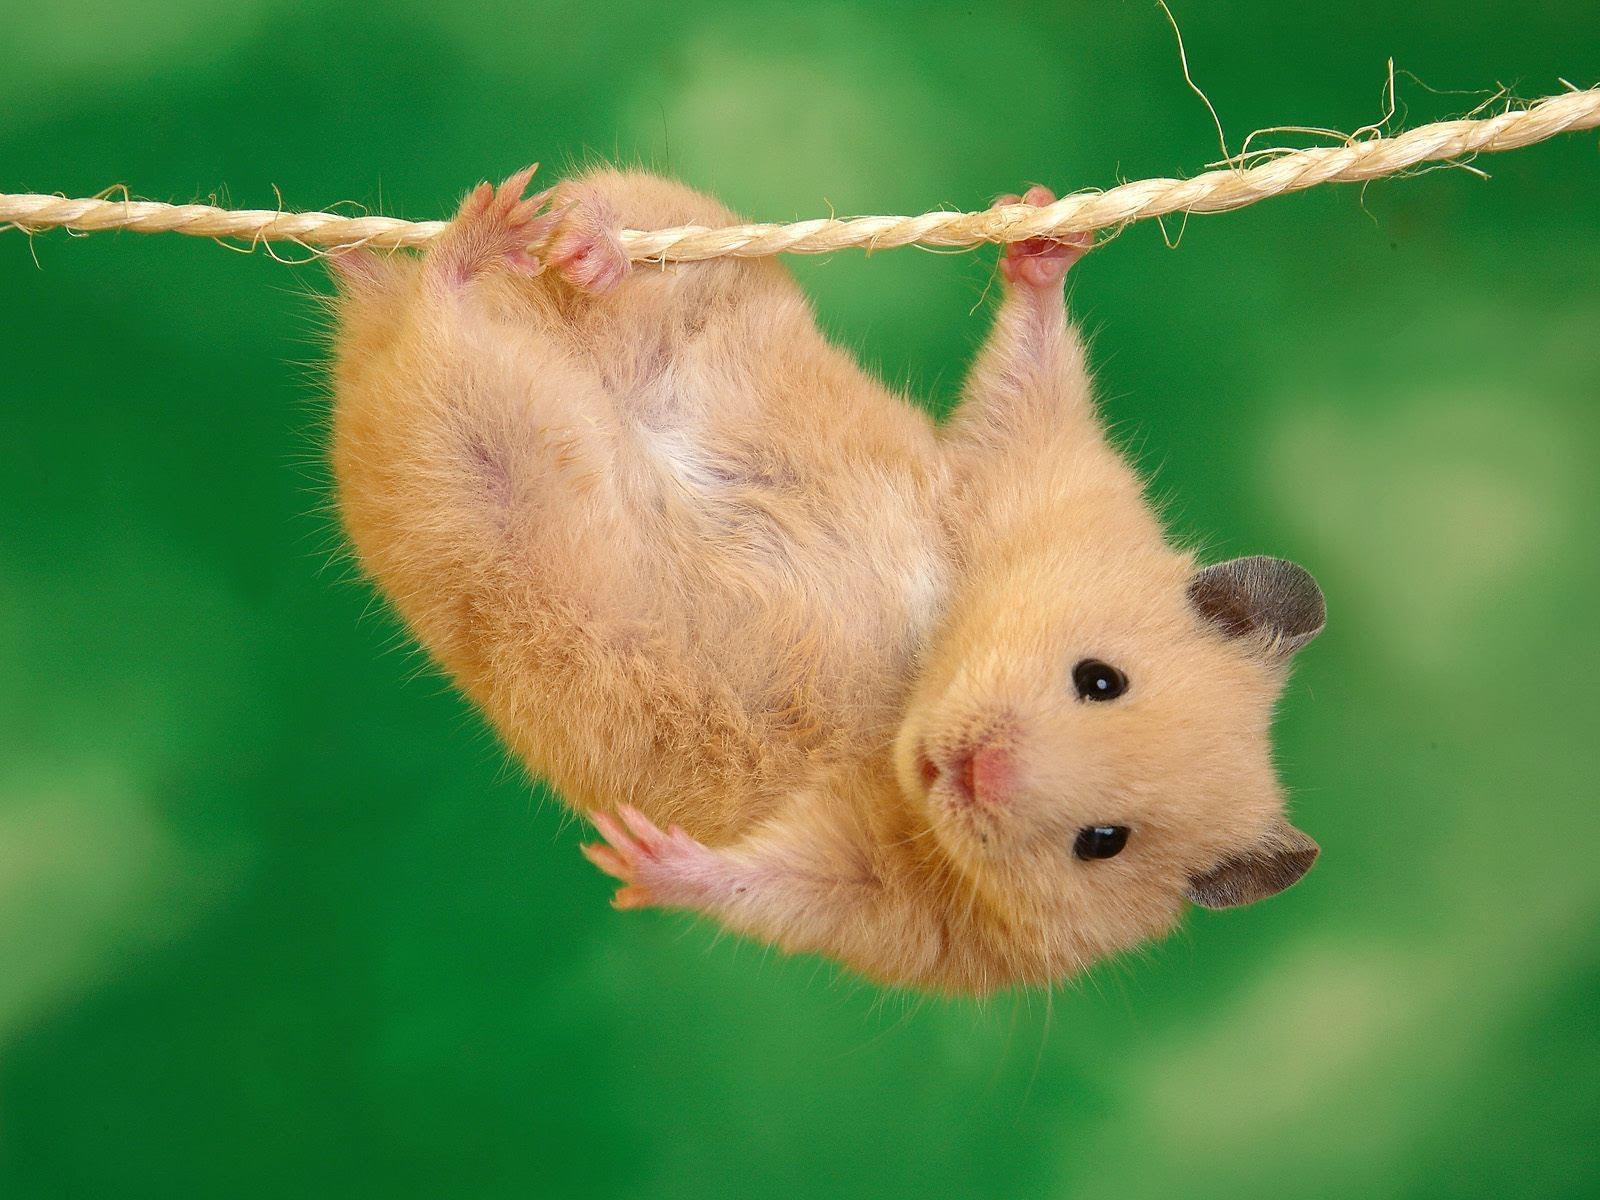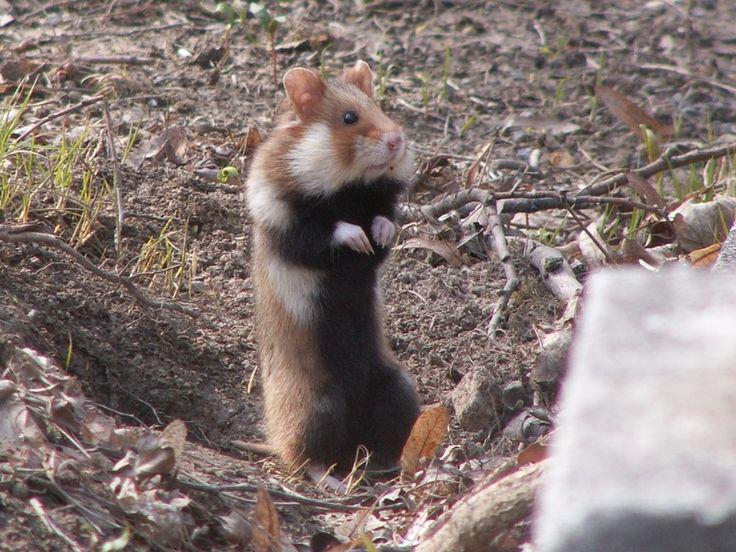The first image is the image on the left, the second image is the image on the right. Considering the images on both sides, is "The left photo contains multiple animals." valid? Answer yes or no. No. The first image is the image on the left, the second image is the image on the right. Assess this claim about the two images: "The animal in the image on the right is in an upright vertical position on its hind legs.". Correct or not? Answer yes or no. Yes. 